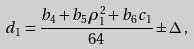<formula> <loc_0><loc_0><loc_500><loc_500>d _ { 1 } = \frac { b _ { 4 } + b _ { 5 } \rho _ { 1 } ^ { 2 } + b _ { 6 } c _ { 1 } } { 6 4 } \pm \Delta \, ,</formula> 